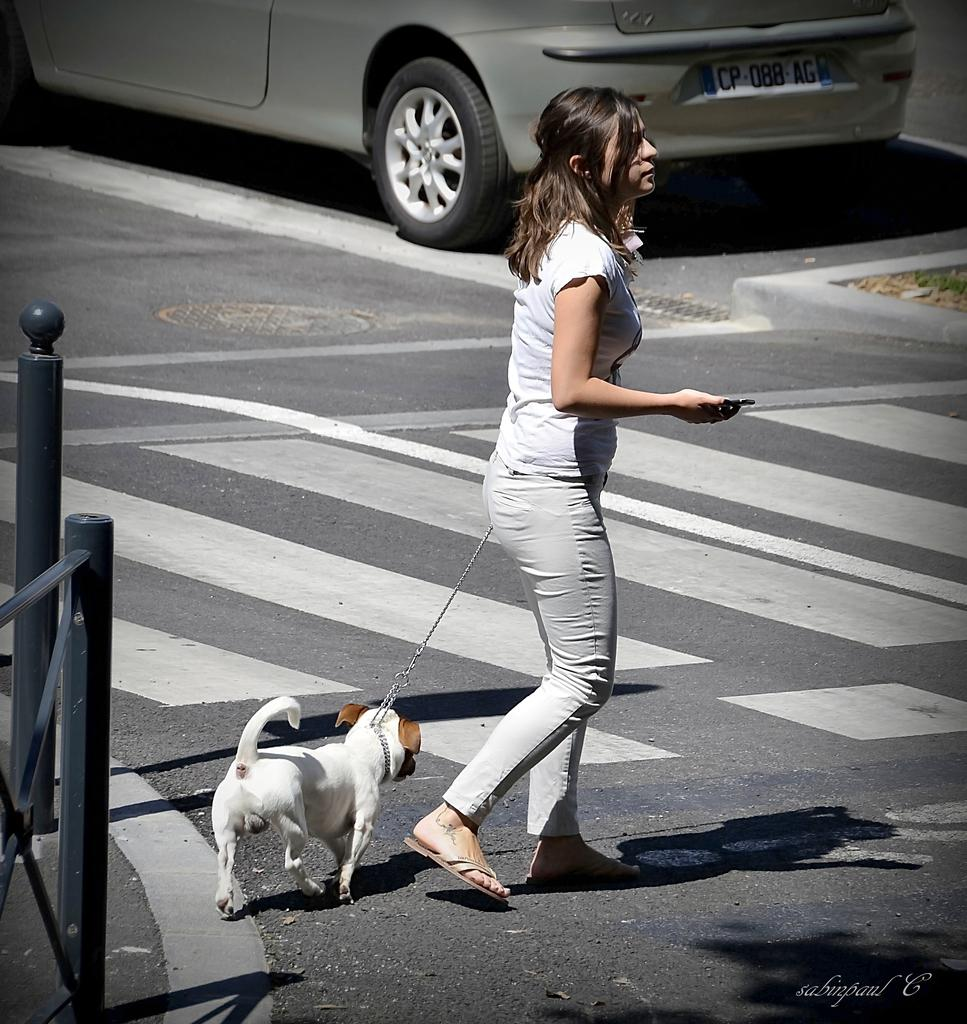Who is the main subject in the image? There is a woman in the image. What is the woman holding in the image? The woman is holding a dog. What can be seen in the background of the image? There is a car visible in the background. What is the woman doing in the image? The woman is walking on the road. How many tin snails are crawling on the road in the image? There are no tin snails present in the image; it features a woman walking on the road while holding a dog. 